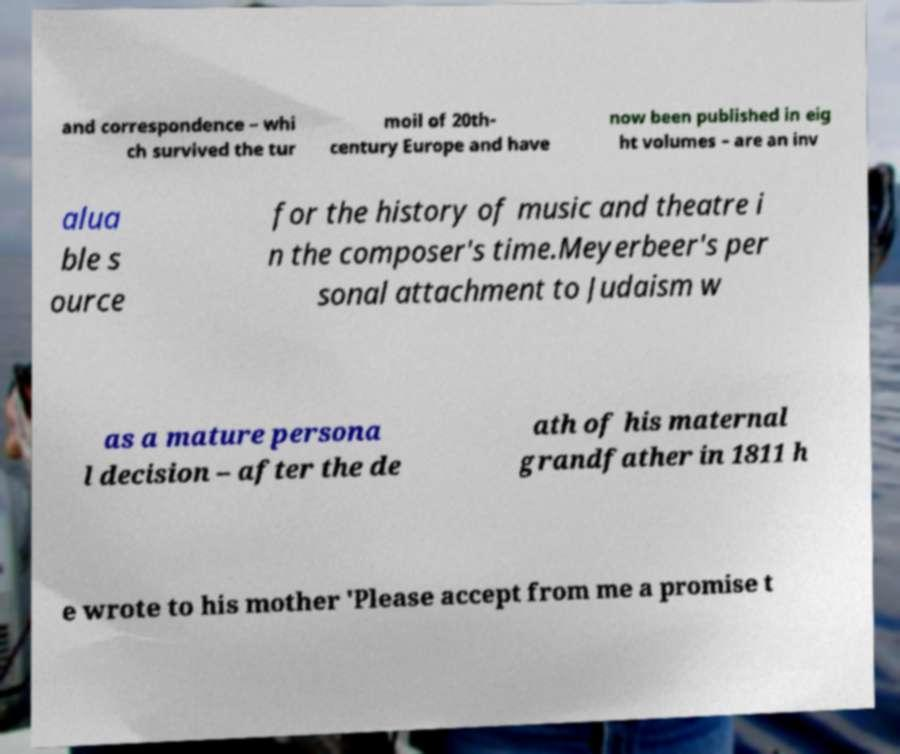I need the written content from this picture converted into text. Can you do that? and correspondence – whi ch survived the tur moil of 20th- century Europe and have now been published in eig ht volumes – are an inv alua ble s ource for the history of music and theatre i n the composer's time.Meyerbeer's per sonal attachment to Judaism w as a mature persona l decision – after the de ath of his maternal grandfather in 1811 h e wrote to his mother 'Please accept from me a promise t 